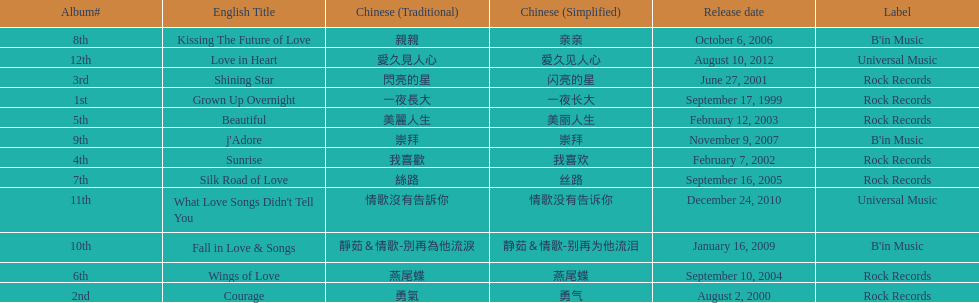Which was the only album to be released by b'in music in an even-numbered year? Kissing The Future of Love. 